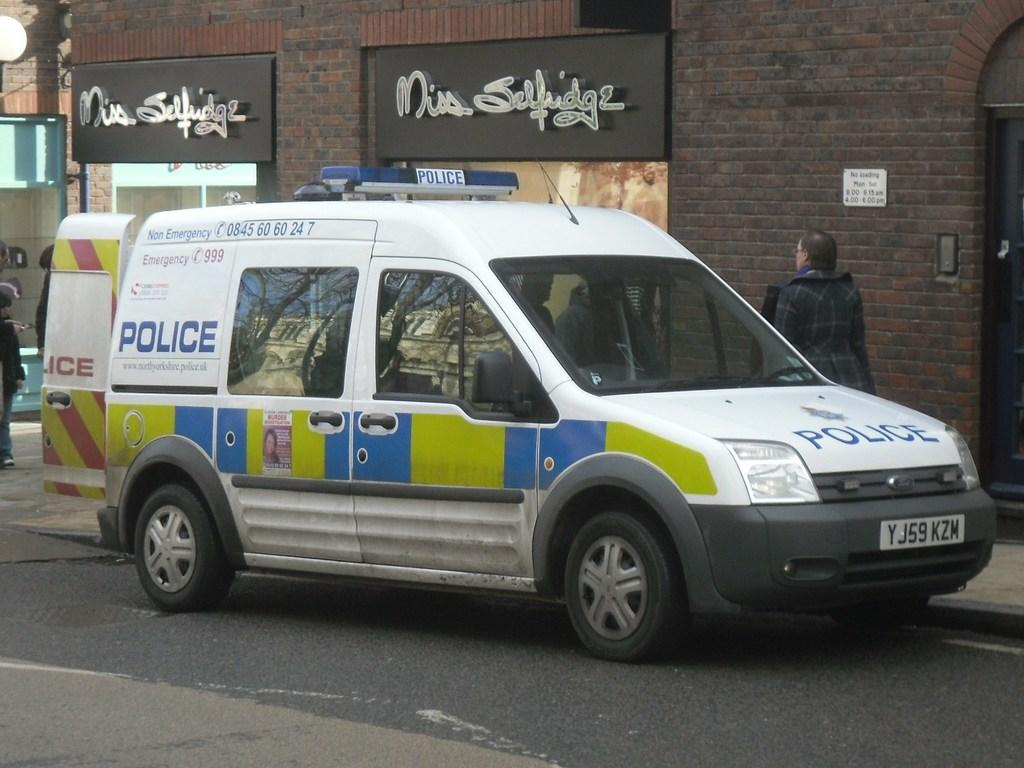What is the main subject in the image? There is a vehicle in the image. Where is the vehicle located in relation to other objects? The vehicle is in front of a wall. What can be seen at the top of the image? There are boards at the top of the image. How many people are visible in the image? There are two people, one on the left side and one on the right side of the image. What type of zephyr can be seen playing the drum in the image? There is no zephyr or drum present in the image. 